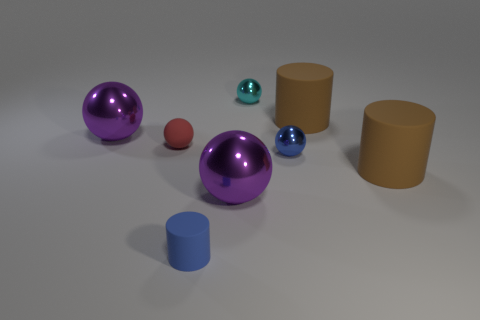What color is the other tiny shiny object that is the same shape as the small cyan metal thing?
Your answer should be compact. Blue. Is the shape of the cyan object the same as the large purple thing left of the red matte thing?
Offer a very short reply. Yes. What number of objects are either big things that are in front of the red object or shiny things in front of the small cyan sphere?
Your answer should be compact. 4. Are there fewer red spheres in front of the small cylinder than brown rubber things?
Give a very brief answer. Yes. Are the small red thing and the small sphere that is right of the small cyan ball made of the same material?
Your answer should be very brief. No. What is the cyan ball made of?
Offer a terse response. Metal. There is a large ball that is on the right side of the small matte thing in front of the big brown matte object in front of the small red object; what is its material?
Ensure brevity in your answer.  Metal. There is a small rubber cylinder; is its color the same as the small rubber thing that is to the left of the tiny matte cylinder?
Offer a very short reply. No. Is there any other thing that is the same shape as the cyan metallic thing?
Ensure brevity in your answer.  Yes. What color is the large metallic thing that is to the right of the small sphere that is to the left of the cyan metal ball?
Keep it short and to the point. Purple. 